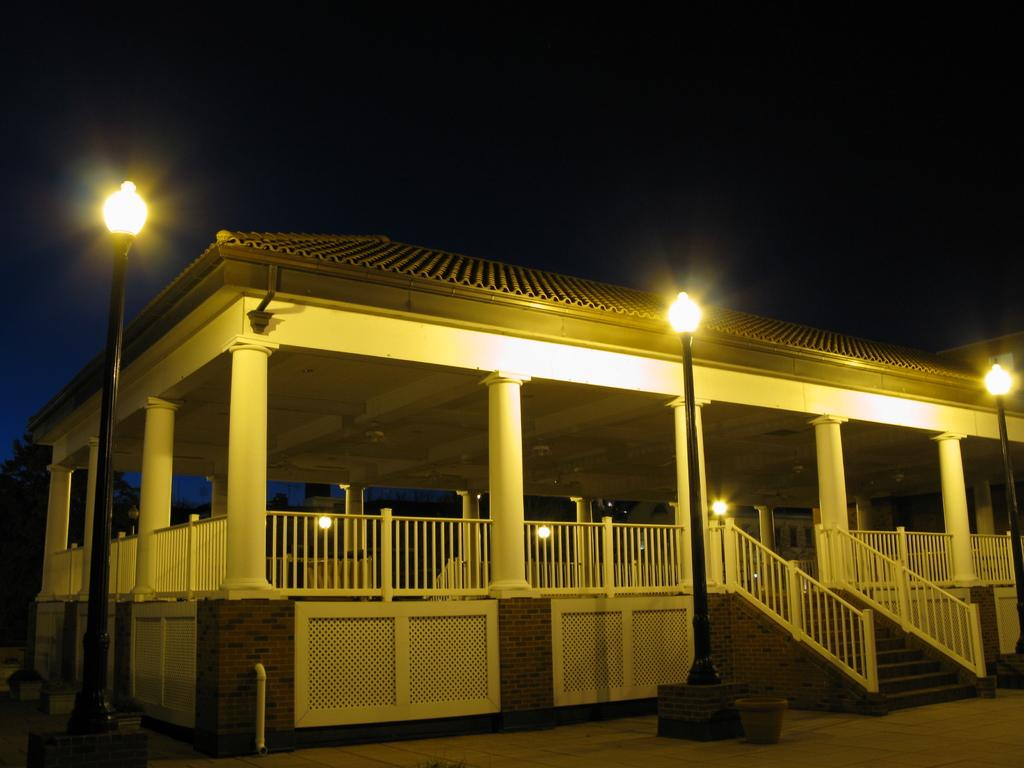What type of structure is present in the image? There is a house in the image. What is visible beneath the house? There is ground visible in the image. What object can be seen on the ground? There is an object on the ground. How can someone access the house in the image? There are stairs in the image, and they have a railing associated with them. What type of lighting is present in the image? There are poles with lights in the image. What type of vegetation is present in the image? There is a tree in the image. What part of the natural environment is visible in the image? The sky is visible in the image. What type of sponge can be seen cleaning the tree in the image? There is no sponge present in the image, and the tree is not being cleaned. 